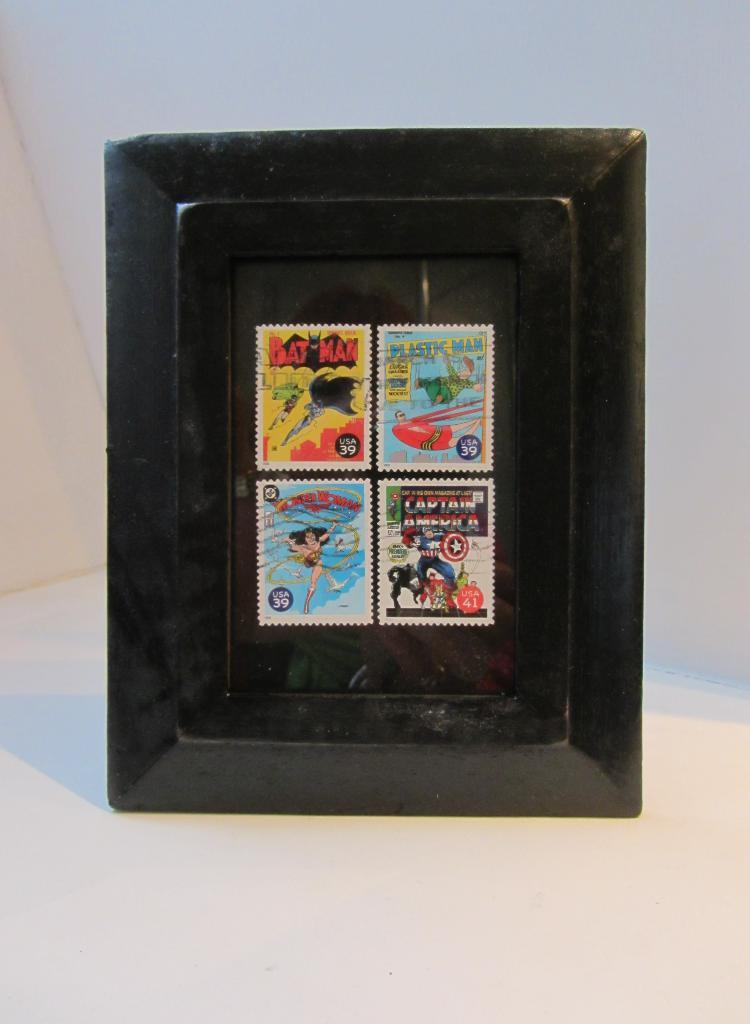<image>
Summarize the visual content of the image. A black frame holding stamps for 39 cent comic book themed stamps. 